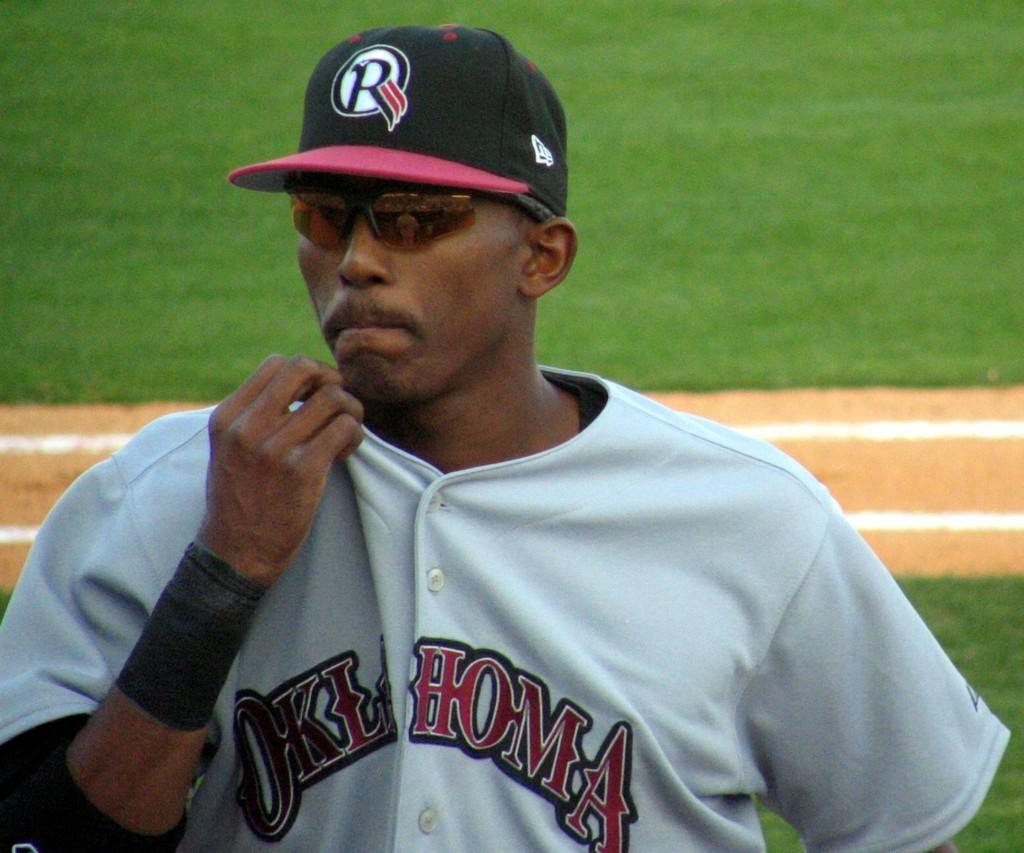<image>
Summarize the visual content of the image. A baseball player wearing a black cap with R on it and a grey top with Oklahoma on it looks across the field. 